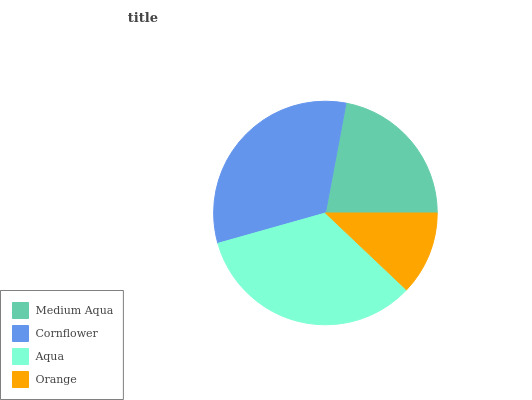Is Orange the minimum?
Answer yes or no. Yes. Is Aqua the maximum?
Answer yes or no. Yes. Is Cornflower the minimum?
Answer yes or no. No. Is Cornflower the maximum?
Answer yes or no. No. Is Cornflower greater than Medium Aqua?
Answer yes or no. Yes. Is Medium Aqua less than Cornflower?
Answer yes or no. Yes. Is Medium Aqua greater than Cornflower?
Answer yes or no. No. Is Cornflower less than Medium Aqua?
Answer yes or no. No. Is Cornflower the high median?
Answer yes or no. Yes. Is Medium Aqua the low median?
Answer yes or no. Yes. Is Orange the high median?
Answer yes or no. No. Is Aqua the low median?
Answer yes or no. No. 